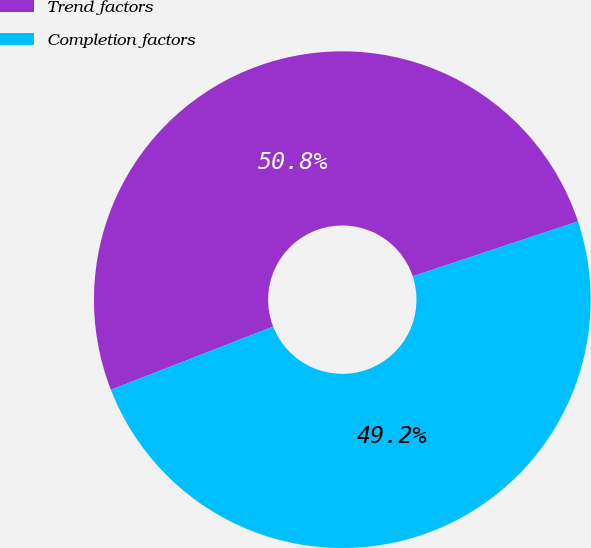<chart> <loc_0><loc_0><loc_500><loc_500><pie_chart><fcel>Trend factors<fcel>Completion factors<nl><fcel>50.81%<fcel>49.19%<nl></chart> 